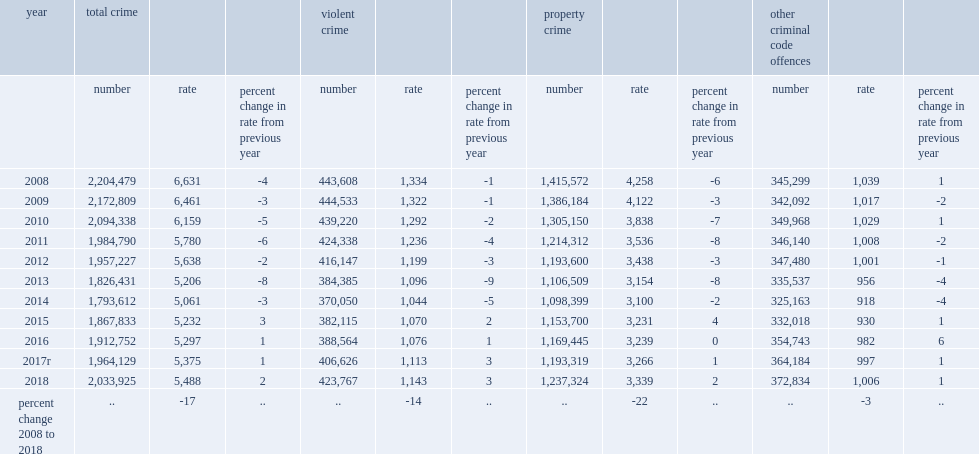How many incidents per 100,000 population, the police-reported crime rate-which measures the volume of crime per 100,000 population in 2018? 5488.0. At 5,488 incidents per 100,000 population, the police-reported crime rate-which measures the volume of crime per 100,000 population, how many percent increased in 2018? 2.0. How many police-reported violent incidents in 2018? 423767.0. There were over 423,700 police-reported violent incidents in 2018, how many incidents were more than the previous year? 17141. There were over 423,700 police-reported violent incidents in 2018, over 17,000 more than the previous year, how many percent of increase in the rate of police-reported violent incidents from the previous year? 3.0. 